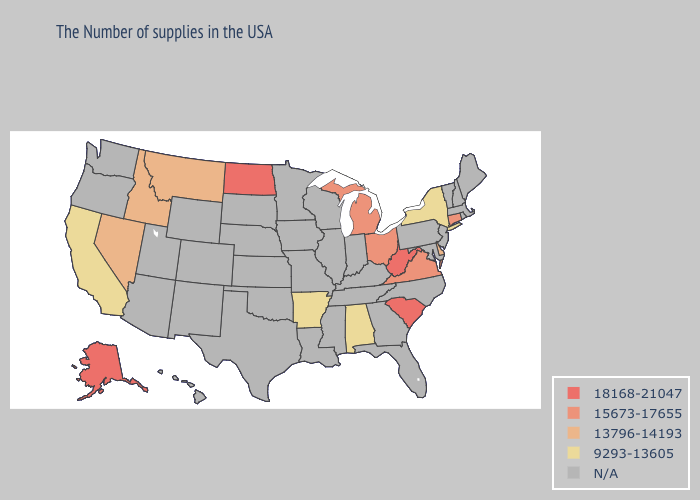Name the states that have a value in the range 18168-21047?
Give a very brief answer. South Carolina, West Virginia, North Dakota, Alaska. Among the states that border Utah , which have the lowest value?
Short answer required. Idaho, Nevada. Name the states that have a value in the range 15673-17655?
Give a very brief answer. Connecticut, Virginia, Ohio, Michigan. Does the map have missing data?
Answer briefly. Yes. Name the states that have a value in the range 13796-14193?
Short answer required. Delaware, Montana, Idaho, Nevada. Name the states that have a value in the range 9293-13605?
Answer briefly. New York, Alabama, Arkansas, California. Name the states that have a value in the range 15673-17655?
Give a very brief answer. Connecticut, Virginia, Ohio, Michigan. Name the states that have a value in the range N/A?
Answer briefly. Maine, Massachusetts, Rhode Island, New Hampshire, Vermont, New Jersey, Maryland, Pennsylvania, North Carolina, Florida, Georgia, Kentucky, Indiana, Tennessee, Wisconsin, Illinois, Mississippi, Louisiana, Missouri, Minnesota, Iowa, Kansas, Nebraska, Oklahoma, Texas, South Dakota, Wyoming, Colorado, New Mexico, Utah, Arizona, Washington, Oregon, Hawaii. What is the highest value in the USA?
Give a very brief answer. 18168-21047. What is the value of California?
Give a very brief answer. 9293-13605. What is the highest value in states that border Indiana?
Concise answer only. 15673-17655. Which states have the highest value in the USA?
Keep it brief. South Carolina, West Virginia, North Dakota, Alaska. 